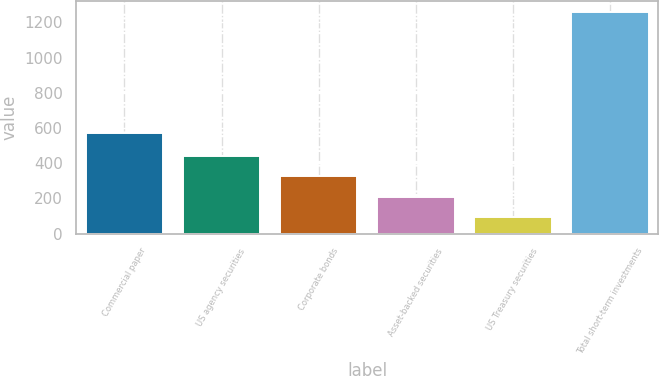<chart> <loc_0><loc_0><loc_500><loc_500><bar_chart><fcel>Commercial paper<fcel>US agency securities<fcel>Corporate bonds<fcel>Asset-backed securities<fcel>US Treasury securities<fcel>Total short-term investments<nl><fcel>573<fcel>442.1<fcel>325.4<fcel>208.7<fcel>92<fcel>1259<nl></chart> 